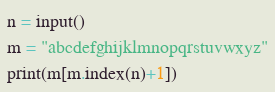<code> <loc_0><loc_0><loc_500><loc_500><_Python_>n = input()
m = "abcdefghijklmnopqrstuvwxyz"
print(m[m.index(n)+1])</code> 